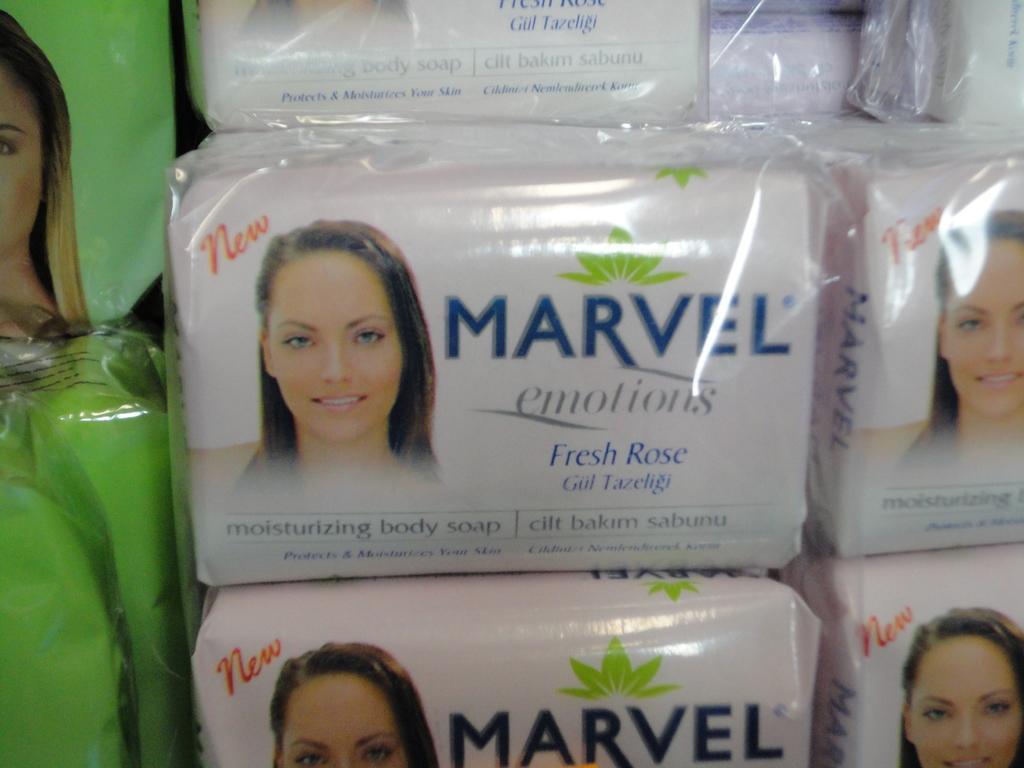Could you give a brief overview of what you see in this image? There are few white color objects which has marvel emotions written on it. 